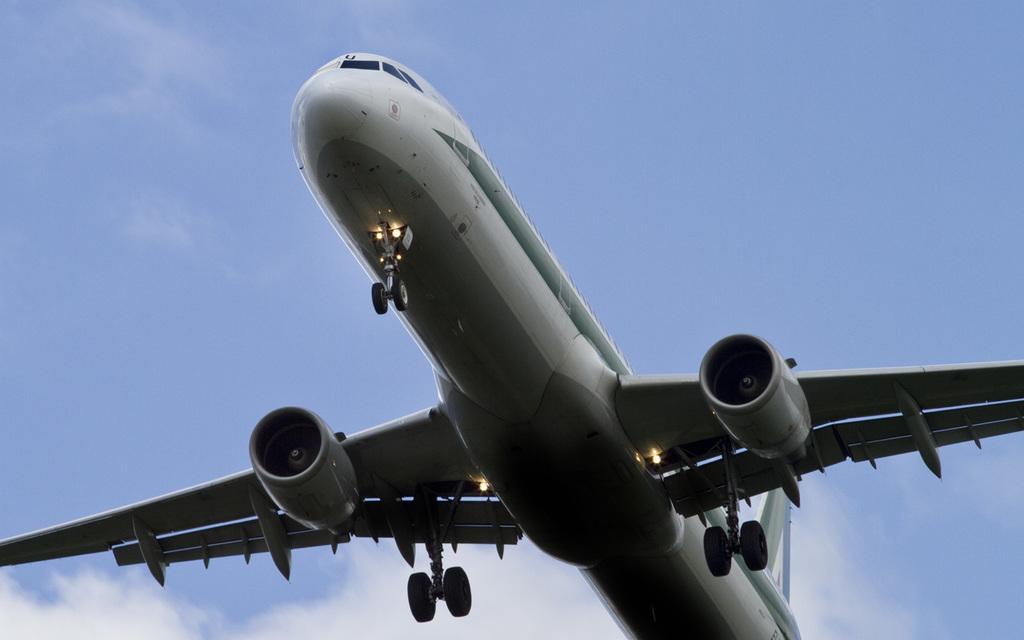Please provide a concise description of this image. In this image there is an airplane flying in the sky. 